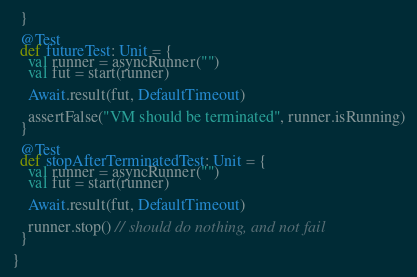<code> <loc_0><loc_0><loc_500><loc_500><_Scala_>  }

  @Test
  def futureTest: Unit = {
    val runner = asyncRunner("")
    val fut = start(runner)

    Await.result(fut, DefaultTimeout)

    assertFalse("VM should be terminated", runner.isRunning)
  }

  @Test
  def stopAfterTerminatedTest: Unit = {
    val runner = asyncRunner("")
    val fut = start(runner)

    Await.result(fut, DefaultTimeout)

    runner.stop() // should do nothing, and not fail
  }

}
</code> 